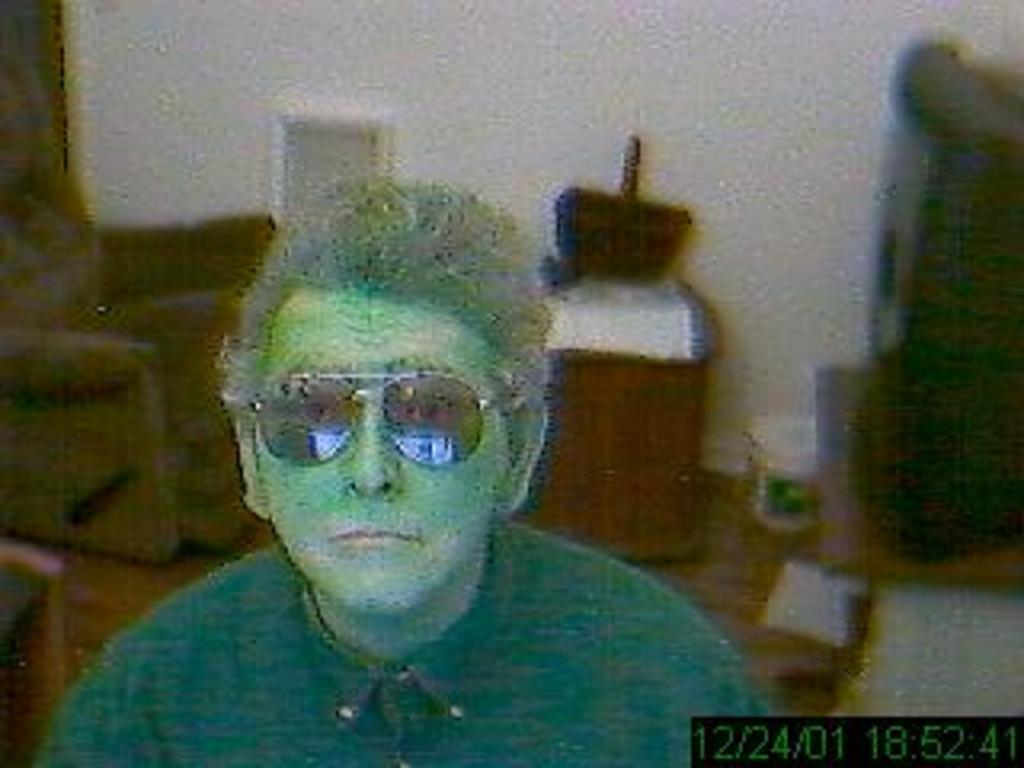What is present in the image? There is a person, a chair, a basket on a wooden desk, and the year, date, month, and time visible on the right side of the image. Can you describe the setting of the image? A wall is visible in the background of the image. What might the person be using the chair for? The person might be sitting on the chair. What is inside the basket? The contents of the basket are not visible in the image. What type of noise can be heard coming from the cherry in the image? There is no cherry present in the image, so it is not possible to determine what noise might be coming from it. 